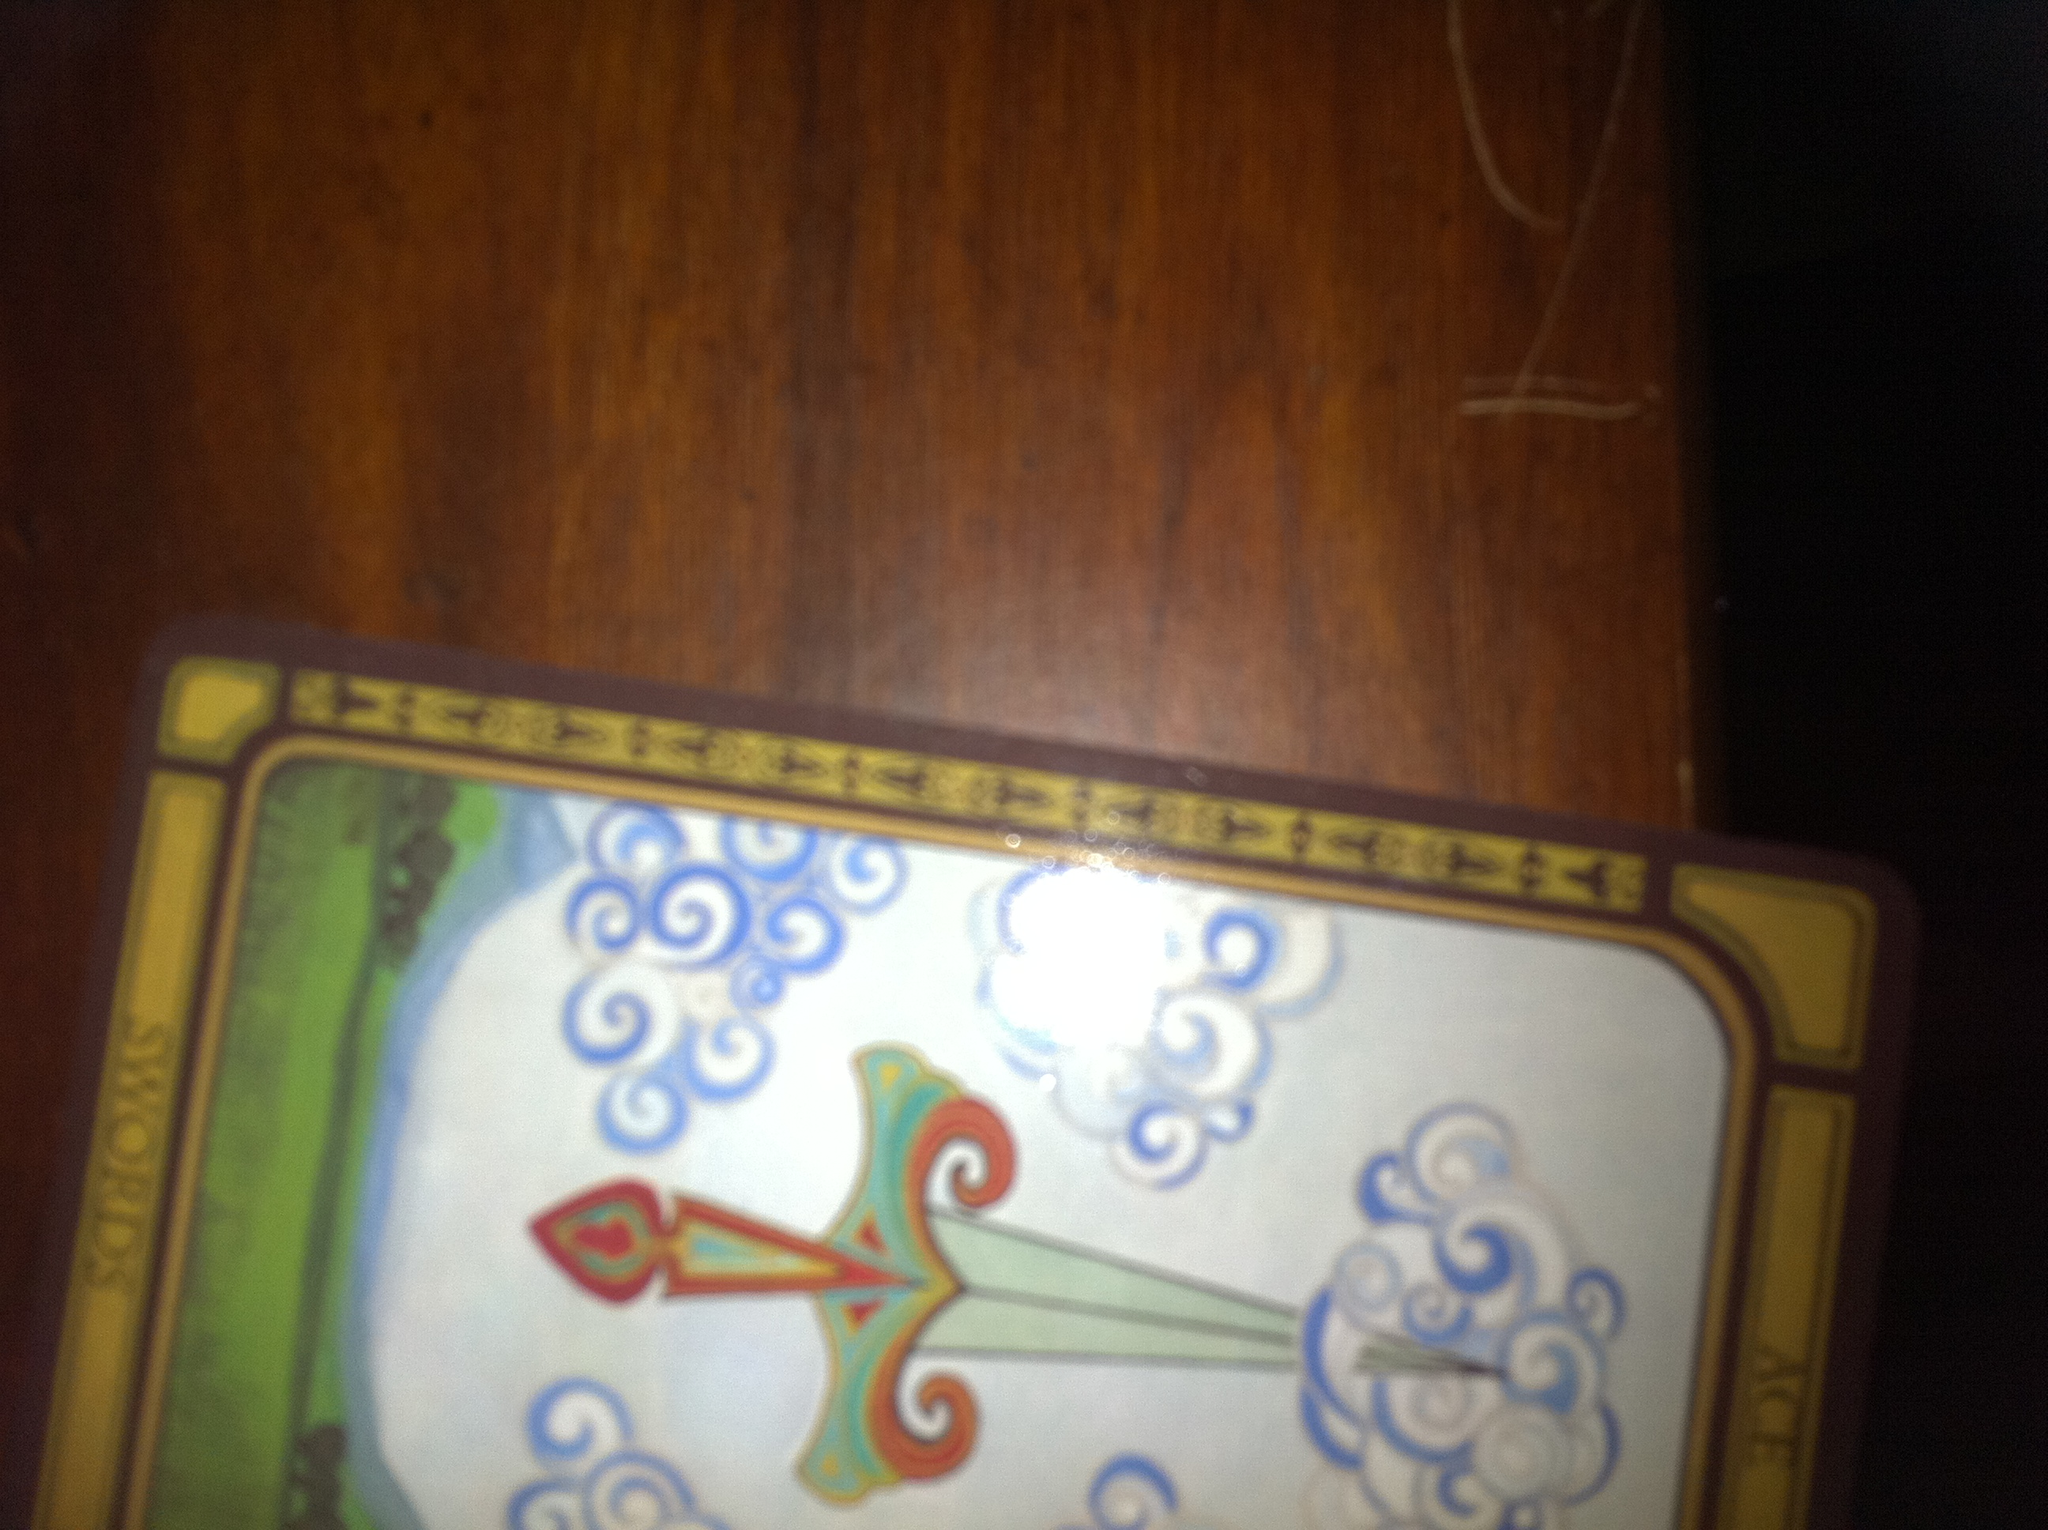What are the different elements represented on this card? This card features a sword with a decorative hilt, piercing through clouds. The background shows a landscape with green fields and a clear sky, symbolizing clarity of thought and the power to cut through confusion. The ornate designs on the sword highlight the importance and significance of mental acuity and sharpness. 